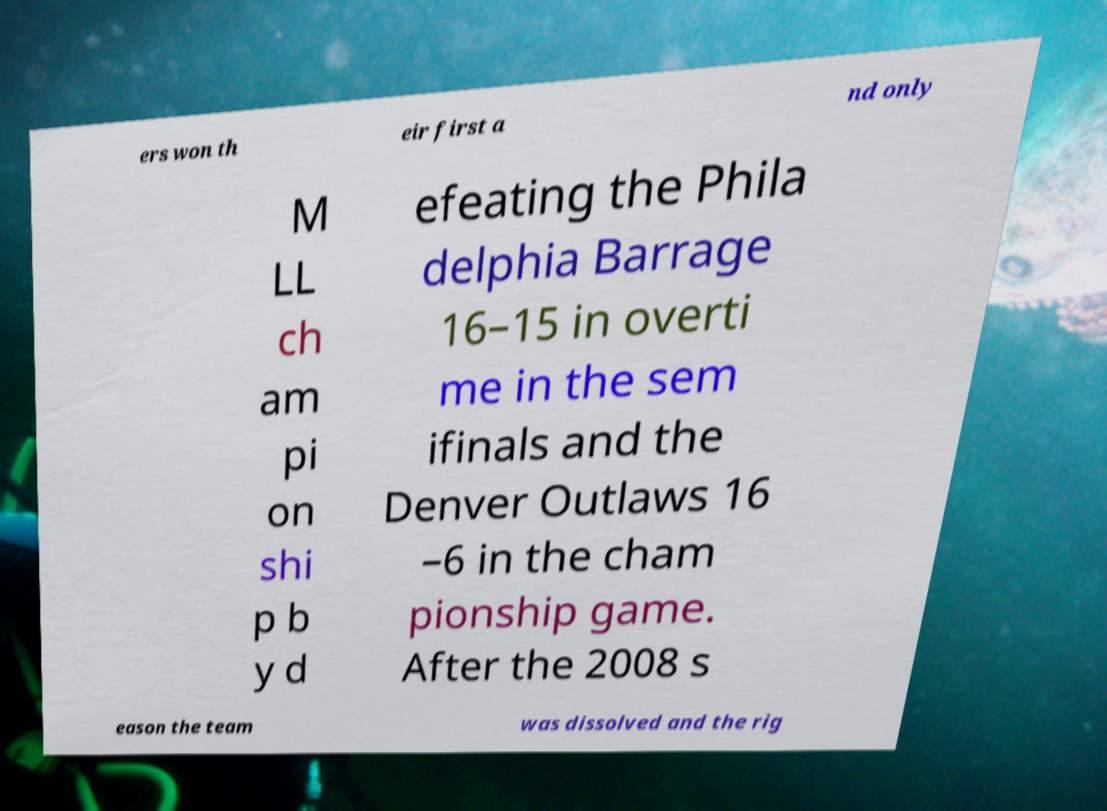Can you accurately transcribe the text from the provided image for me? ers won th eir first a nd only M LL ch am pi on shi p b y d efeating the Phila delphia Barrage 16–15 in overti me in the sem ifinals and the Denver Outlaws 16 –6 in the cham pionship game. After the 2008 s eason the team was dissolved and the rig 